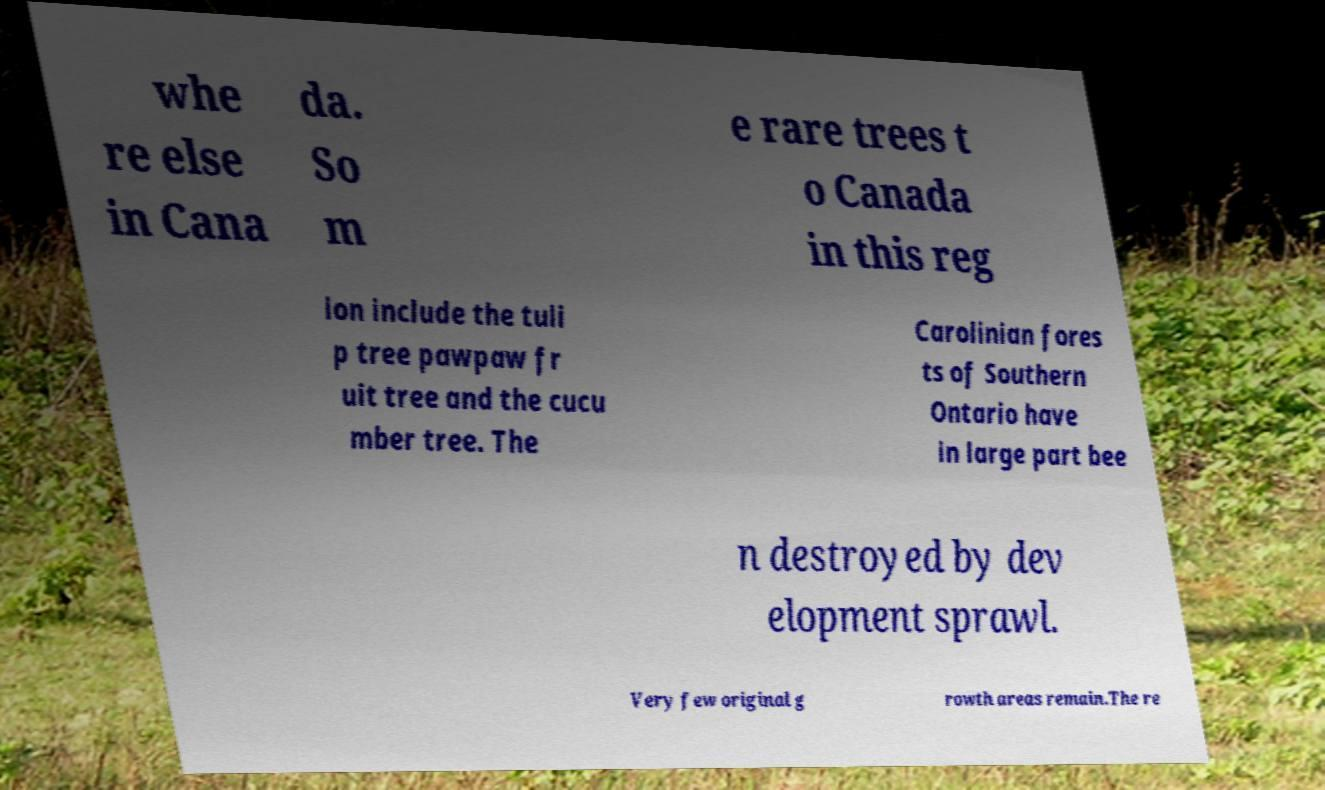Please read and relay the text visible in this image. What does it say? whe re else in Cana da. So m e rare trees t o Canada in this reg ion include the tuli p tree pawpaw fr uit tree and the cucu mber tree. The Carolinian fores ts of Southern Ontario have in large part bee n destroyed by dev elopment sprawl. Very few original g rowth areas remain.The re 